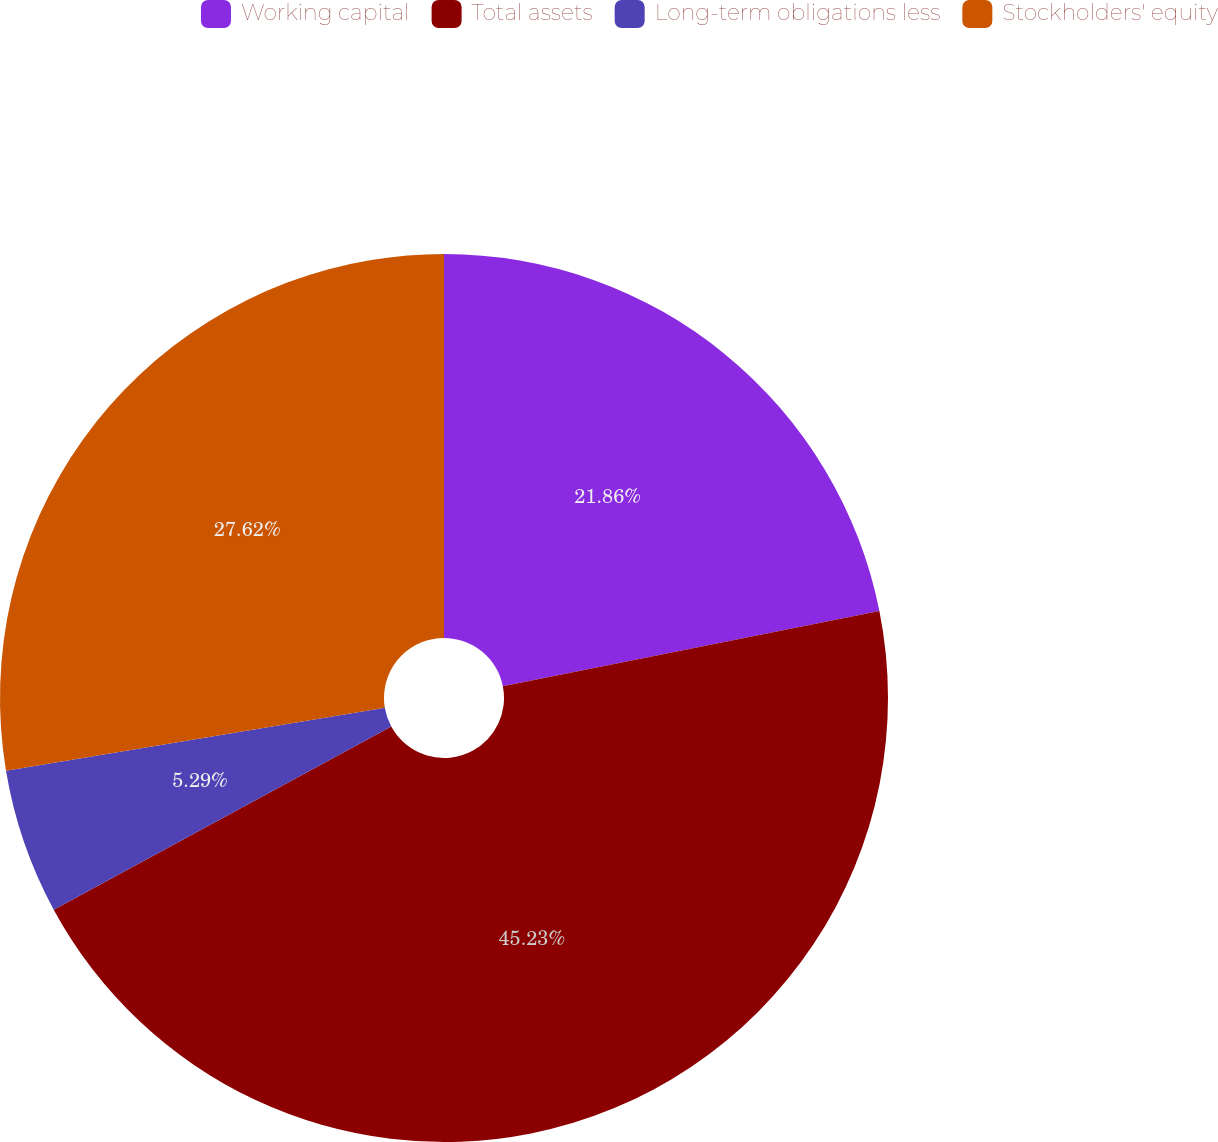<chart> <loc_0><loc_0><loc_500><loc_500><pie_chart><fcel>Working capital<fcel>Total assets<fcel>Long-term obligations less<fcel>Stockholders' equity<nl><fcel>21.86%<fcel>45.23%<fcel>5.29%<fcel>27.62%<nl></chart> 